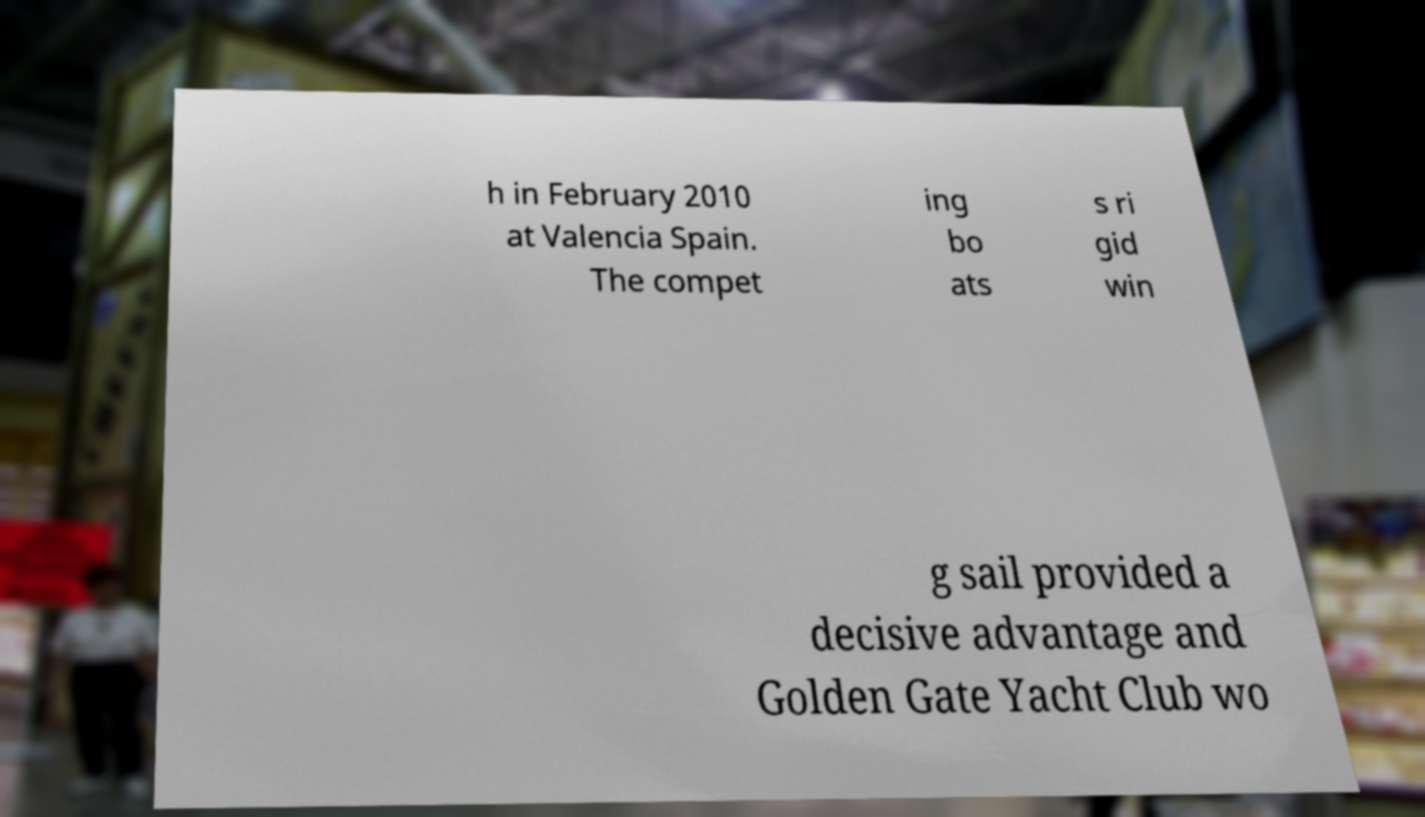I need the written content from this picture converted into text. Can you do that? h in February 2010 at Valencia Spain. The compet ing bo ats s ri gid win g sail provided a decisive advantage and Golden Gate Yacht Club wo 